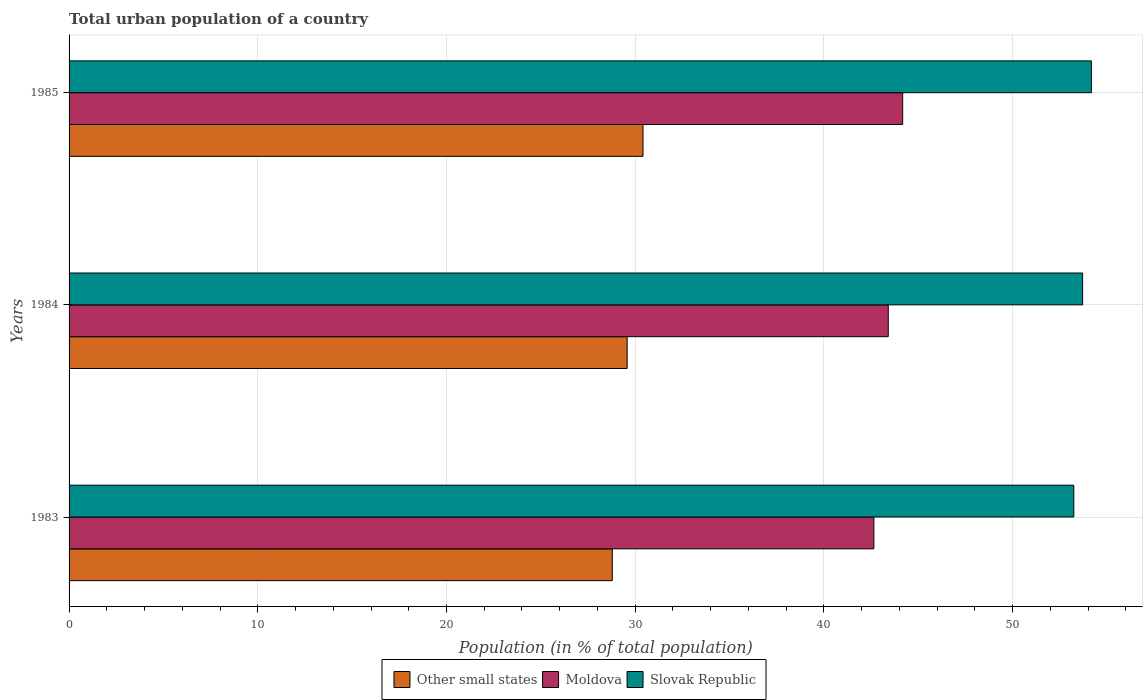How many groups of bars are there?
Your response must be concise. 3. Are the number of bars per tick equal to the number of legend labels?
Make the answer very short. Yes. How many bars are there on the 3rd tick from the top?
Your response must be concise. 3. What is the label of the 2nd group of bars from the top?
Give a very brief answer. 1984. In how many cases, is the number of bars for a given year not equal to the number of legend labels?
Make the answer very short. 0. What is the urban population in Slovak Republic in 1983?
Give a very brief answer. 53.24. Across all years, what is the maximum urban population in Other small states?
Give a very brief answer. 30.42. Across all years, what is the minimum urban population in Moldova?
Offer a very short reply. 42.65. In which year was the urban population in Slovak Republic minimum?
Provide a short and direct response. 1983. What is the total urban population in Slovak Republic in the graph?
Make the answer very short. 161.13. What is the difference between the urban population in Slovak Republic in 1983 and that in 1985?
Your answer should be compact. -0.93. What is the difference between the urban population in Slovak Republic in 1983 and the urban population in Moldova in 1984?
Provide a short and direct response. 9.83. What is the average urban population in Moldova per year?
Your answer should be compact. 43.41. In the year 1983, what is the difference between the urban population in Other small states and urban population in Slovak Republic?
Provide a short and direct response. -24.46. In how many years, is the urban population in Slovak Republic greater than 8 %?
Your answer should be compact. 3. What is the ratio of the urban population in Slovak Republic in 1983 to that in 1985?
Offer a very short reply. 0.98. Is the urban population in Slovak Republic in 1983 less than that in 1984?
Your response must be concise. Yes. Is the difference between the urban population in Other small states in 1983 and 1985 greater than the difference between the urban population in Slovak Republic in 1983 and 1985?
Ensure brevity in your answer.  No. What is the difference between the highest and the second highest urban population in Slovak Republic?
Give a very brief answer. 0.46. What is the difference between the highest and the lowest urban population in Slovak Republic?
Provide a succinct answer. 0.93. Is the sum of the urban population in Moldova in 1983 and 1984 greater than the maximum urban population in Slovak Republic across all years?
Provide a short and direct response. Yes. What does the 2nd bar from the top in 1984 represents?
Make the answer very short. Moldova. What does the 3rd bar from the bottom in 1984 represents?
Keep it short and to the point. Slovak Republic. Is it the case that in every year, the sum of the urban population in Moldova and urban population in Other small states is greater than the urban population in Slovak Republic?
Provide a succinct answer. Yes. Are all the bars in the graph horizontal?
Make the answer very short. Yes. How many years are there in the graph?
Make the answer very short. 3. Are the values on the major ticks of X-axis written in scientific E-notation?
Ensure brevity in your answer.  No. Does the graph contain any zero values?
Provide a short and direct response. No. Does the graph contain grids?
Offer a terse response. Yes. How many legend labels are there?
Your answer should be compact. 3. What is the title of the graph?
Provide a short and direct response. Total urban population of a country. What is the label or title of the X-axis?
Give a very brief answer. Population (in % of total population). What is the label or title of the Y-axis?
Offer a terse response. Years. What is the Population (in % of total population) in Other small states in 1983?
Your answer should be compact. 28.79. What is the Population (in % of total population) in Moldova in 1983?
Provide a short and direct response. 42.65. What is the Population (in % of total population) in Slovak Republic in 1983?
Offer a very short reply. 53.24. What is the Population (in % of total population) in Other small states in 1984?
Give a very brief answer. 29.58. What is the Population (in % of total population) of Moldova in 1984?
Provide a short and direct response. 43.41. What is the Population (in % of total population) of Slovak Republic in 1984?
Your answer should be very brief. 53.71. What is the Population (in % of total population) in Other small states in 1985?
Provide a succinct answer. 30.42. What is the Population (in % of total population) of Moldova in 1985?
Your answer should be compact. 44.18. What is the Population (in % of total population) of Slovak Republic in 1985?
Your answer should be compact. 54.18. Across all years, what is the maximum Population (in % of total population) of Other small states?
Your answer should be compact. 30.42. Across all years, what is the maximum Population (in % of total population) of Moldova?
Keep it short and to the point. 44.18. Across all years, what is the maximum Population (in % of total population) of Slovak Republic?
Your response must be concise. 54.18. Across all years, what is the minimum Population (in % of total population) of Other small states?
Your response must be concise. 28.79. Across all years, what is the minimum Population (in % of total population) in Moldova?
Offer a very short reply. 42.65. Across all years, what is the minimum Population (in % of total population) in Slovak Republic?
Your response must be concise. 53.24. What is the total Population (in % of total population) in Other small states in the graph?
Make the answer very short. 88.78. What is the total Population (in % of total population) of Moldova in the graph?
Offer a terse response. 130.24. What is the total Population (in % of total population) of Slovak Republic in the graph?
Offer a terse response. 161.13. What is the difference between the Population (in % of total population) in Other small states in 1983 and that in 1984?
Give a very brief answer. -0.79. What is the difference between the Population (in % of total population) of Moldova in 1983 and that in 1984?
Offer a very short reply. -0.76. What is the difference between the Population (in % of total population) of Slovak Republic in 1983 and that in 1984?
Your response must be concise. -0.47. What is the difference between the Population (in % of total population) of Other small states in 1983 and that in 1985?
Provide a succinct answer. -1.63. What is the difference between the Population (in % of total population) in Moldova in 1983 and that in 1985?
Your response must be concise. -1.53. What is the difference between the Population (in % of total population) of Slovak Republic in 1983 and that in 1985?
Offer a terse response. -0.93. What is the difference between the Population (in % of total population) in Other small states in 1984 and that in 1985?
Provide a succinct answer. -0.84. What is the difference between the Population (in % of total population) of Moldova in 1984 and that in 1985?
Make the answer very short. -0.76. What is the difference between the Population (in % of total population) of Slovak Republic in 1984 and that in 1985?
Give a very brief answer. -0.47. What is the difference between the Population (in % of total population) of Other small states in 1983 and the Population (in % of total population) of Moldova in 1984?
Your response must be concise. -14.62. What is the difference between the Population (in % of total population) in Other small states in 1983 and the Population (in % of total population) in Slovak Republic in 1984?
Provide a succinct answer. -24.92. What is the difference between the Population (in % of total population) of Moldova in 1983 and the Population (in % of total population) of Slovak Republic in 1984?
Your answer should be very brief. -11.06. What is the difference between the Population (in % of total population) in Other small states in 1983 and the Population (in % of total population) in Moldova in 1985?
Provide a short and direct response. -15.39. What is the difference between the Population (in % of total population) in Other small states in 1983 and the Population (in % of total population) in Slovak Republic in 1985?
Provide a succinct answer. -25.39. What is the difference between the Population (in % of total population) of Moldova in 1983 and the Population (in % of total population) of Slovak Republic in 1985?
Offer a terse response. -11.53. What is the difference between the Population (in % of total population) of Other small states in 1984 and the Population (in % of total population) of Moldova in 1985?
Your response must be concise. -14.6. What is the difference between the Population (in % of total population) in Other small states in 1984 and the Population (in % of total population) in Slovak Republic in 1985?
Provide a short and direct response. -24.6. What is the difference between the Population (in % of total population) of Moldova in 1984 and the Population (in % of total population) of Slovak Republic in 1985?
Provide a succinct answer. -10.76. What is the average Population (in % of total population) of Other small states per year?
Ensure brevity in your answer.  29.59. What is the average Population (in % of total population) of Moldova per year?
Your answer should be compact. 43.41. What is the average Population (in % of total population) of Slovak Republic per year?
Provide a short and direct response. 53.71. In the year 1983, what is the difference between the Population (in % of total population) of Other small states and Population (in % of total population) of Moldova?
Your response must be concise. -13.86. In the year 1983, what is the difference between the Population (in % of total population) of Other small states and Population (in % of total population) of Slovak Republic?
Your response must be concise. -24.46. In the year 1983, what is the difference between the Population (in % of total population) of Moldova and Population (in % of total population) of Slovak Republic?
Give a very brief answer. -10.6. In the year 1984, what is the difference between the Population (in % of total population) of Other small states and Population (in % of total population) of Moldova?
Give a very brief answer. -13.84. In the year 1984, what is the difference between the Population (in % of total population) in Other small states and Population (in % of total population) in Slovak Republic?
Offer a terse response. -24.14. In the year 1984, what is the difference between the Population (in % of total population) in Moldova and Population (in % of total population) in Slovak Republic?
Provide a short and direct response. -10.3. In the year 1985, what is the difference between the Population (in % of total population) of Other small states and Population (in % of total population) of Moldova?
Keep it short and to the point. -13.76. In the year 1985, what is the difference between the Population (in % of total population) in Other small states and Population (in % of total population) in Slovak Republic?
Your answer should be very brief. -23.76. What is the ratio of the Population (in % of total population) of Other small states in 1983 to that in 1984?
Make the answer very short. 0.97. What is the ratio of the Population (in % of total population) of Moldova in 1983 to that in 1984?
Offer a very short reply. 0.98. What is the ratio of the Population (in % of total population) of Other small states in 1983 to that in 1985?
Ensure brevity in your answer.  0.95. What is the ratio of the Population (in % of total population) of Moldova in 1983 to that in 1985?
Provide a short and direct response. 0.97. What is the ratio of the Population (in % of total population) of Slovak Republic in 1983 to that in 1985?
Your answer should be compact. 0.98. What is the ratio of the Population (in % of total population) in Other small states in 1984 to that in 1985?
Give a very brief answer. 0.97. What is the ratio of the Population (in % of total population) in Moldova in 1984 to that in 1985?
Make the answer very short. 0.98. What is the ratio of the Population (in % of total population) in Slovak Republic in 1984 to that in 1985?
Your answer should be very brief. 0.99. What is the difference between the highest and the second highest Population (in % of total population) of Other small states?
Your answer should be very brief. 0.84. What is the difference between the highest and the second highest Population (in % of total population) in Moldova?
Your answer should be very brief. 0.76. What is the difference between the highest and the second highest Population (in % of total population) of Slovak Republic?
Provide a succinct answer. 0.47. What is the difference between the highest and the lowest Population (in % of total population) of Other small states?
Provide a short and direct response. 1.63. What is the difference between the highest and the lowest Population (in % of total population) in Moldova?
Make the answer very short. 1.53. What is the difference between the highest and the lowest Population (in % of total population) in Slovak Republic?
Offer a terse response. 0.93. 